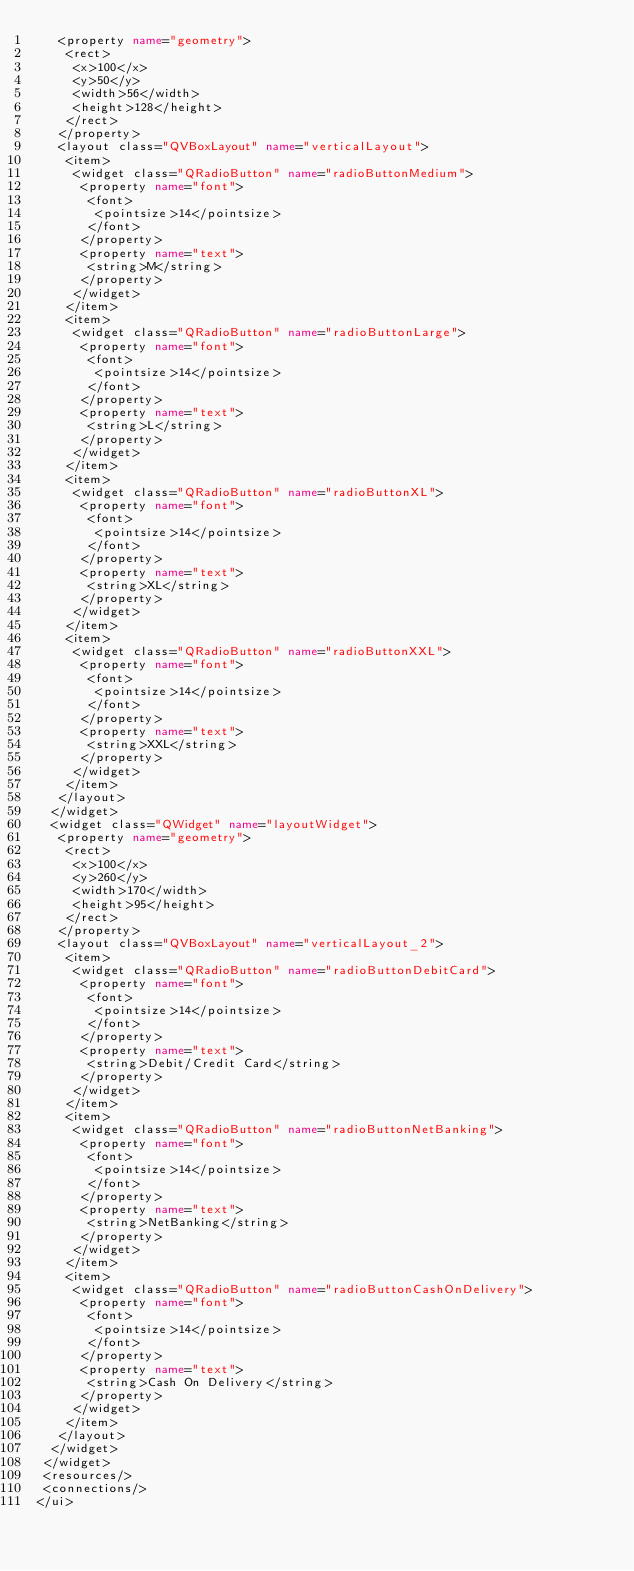<code> <loc_0><loc_0><loc_500><loc_500><_XML_>   <property name="geometry">
    <rect>
     <x>100</x>
     <y>50</y>
     <width>56</width>
     <height>128</height>
    </rect>
   </property>
   <layout class="QVBoxLayout" name="verticalLayout">
    <item>
     <widget class="QRadioButton" name="radioButtonMedium">
      <property name="font">
       <font>
        <pointsize>14</pointsize>
       </font>
      </property>
      <property name="text">
       <string>M</string>
      </property>
     </widget>
    </item>
    <item>
     <widget class="QRadioButton" name="radioButtonLarge">
      <property name="font">
       <font>
        <pointsize>14</pointsize>
       </font>
      </property>
      <property name="text">
       <string>L</string>
      </property>
     </widget>
    </item>
    <item>
     <widget class="QRadioButton" name="radioButtonXL">
      <property name="font">
       <font>
        <pointsize>14</pointsize>
       </font>
      </property>
      <property name="text">
       <string>XL</string>
      </property>
     </widget>
    </item>
    <item>
     <widget class="QRadioButton" name="radioButtonXXL">
      <property name="font">
       <font>
        <pointsize>14</pointsize>
       </font>
      </property>
      <property name="text">
       <string>XXL</string>
      </property>
     </widget>
    </item>
   </layout>
  </widget>
  <widget class="QWidget" name="layoutWidget">
   <property name="geometry">
    <rect>
     <x>100</x>
     <y>260</y>
     <width>170</width>
     <height>95</height>
    </rect>
   </property>
   <layout class="QVBoxLayout" name="verticalLayout_2">
    <item>
     <widget class="QRadioButton" name="radioButtonDebitCard">
      <property name="font">
       <font>
        <pointsize>14</pointsize>
       </font>
      </property>
      <property name="text">
       <string>Debit/Credit Card</string>
      </property>
     </widget>
    </item>
    <item>
     <widget class="QRadioButton" name="radioButtonNetBanking">
      <property name="font">
       <font>
        <pointsize>14</pointsize>
       </font>
      </property>
      <property name="text">
       <string>NetBanking</string>
      </property>
     </widget>
    </item>
    <item>
     <widget class="QRadioButton" name="radioButtonCashOnDelivery">
      <property name="font">
       <font>
        <pointsize>14</pointsize>
       </font>
      </property>
      <property name="text">
       <string>Cash On Delivery</string>
      </property>
     </widget>
    </item>
   </layout>
  </widget>
 </widget>
 <resources/>
 <connections/>
</ui>
</code> 